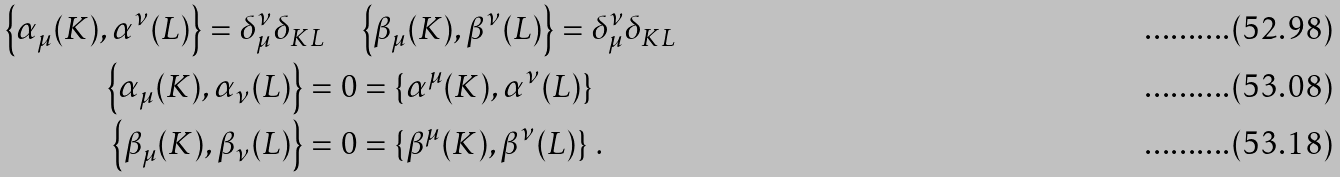Convert formula to latex. <formula><loc_0><loc_0><loc_500><loc_500>\left \{ \alpha _ { \mu } ( K ) , \alpha ^ { \nu } ( L ) \right \} = \delta _ { \mu } ^ { \nu } \delta _ { K L } \quad & \left \{ \beta _ { \mu } ( K ) , \beta ^ { \nu } ( L ) \right \} = \delta _ { \mu } ^ { \nu } \delta _ { K L } \\ \left \{ \alpha _ { \mu } ( K ) , \alpha _ { \nu } ( L ) \right \} = 0 & = \left \{ \alpha ^ { \mu } ( K ) , \alpha ^ { \nu } ( L ) \right \} \\ \left \{ \beta _ { \mu } ( K ) , \beta _ { \nu } ( L ) \right \} = 0 & = \left \{ \beta ^ { \mu } ( K ) , \beta ^ { \nu } ( L ) \right \} \, .</formula> 